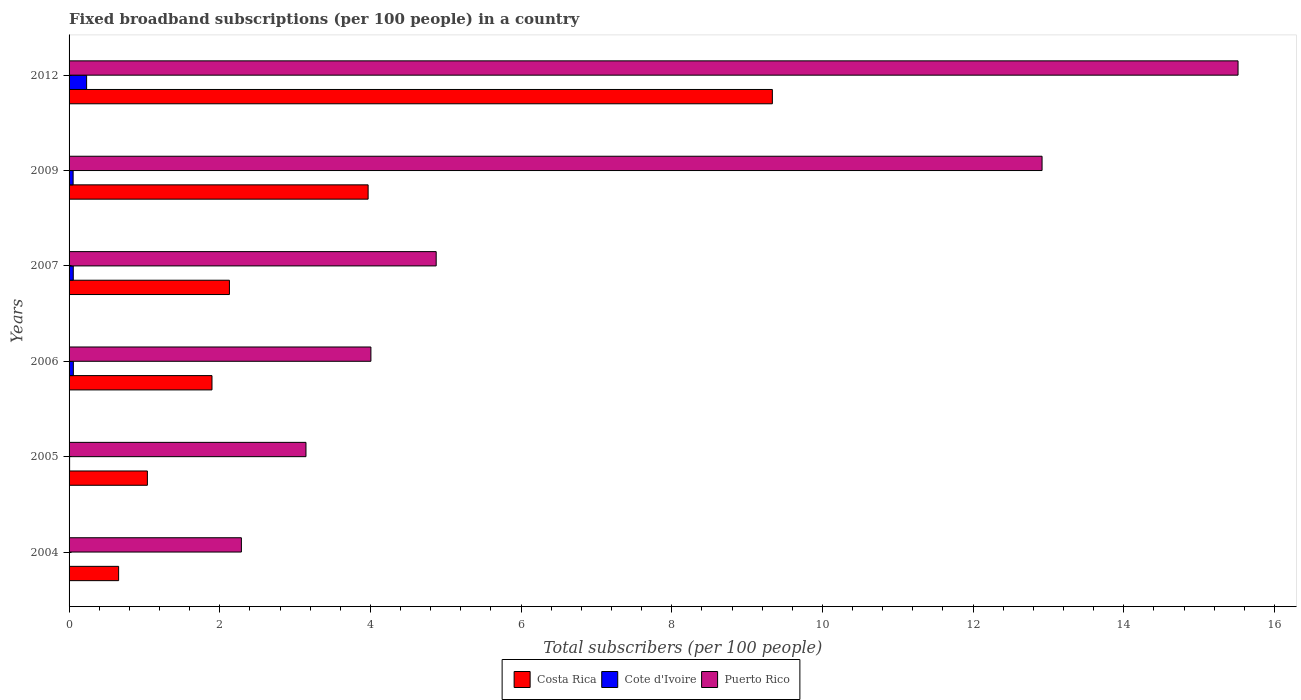How many different coloured bars are there?
Give a very brief answer. 3. How many groups of bars are there?
Make the answer very short. 6. Are the number of bars per tick equal to the number of legend labels?
Your answer should be very brief. Yes. How many bars are there on the 3rd tick from the bottom?
Give a very brief answer. 3. What is the label of the 4th group of bars from the top?
Keep it short and to the point. 2006. In how many cases, is the number of bars for a given year not equal to the number of legend labels?
Provide a short and direct response. 0. What is the number of broadband subscriptions in Costa Rica in 2009?
Provide a succinct answer. 3.97. Across all years, what is the maximum number of broadband subscriptions in Cote d'Ivoire?
Provide a succinct answer. 0.23. Across all years, what is the minimum number of broadband subscriptions in Cote d'Ivoire?
Offer a terse response. 0. In which year was the number of broadband subscriptions in Costa Rica minimum?
Keep it short and to the point. 2004. What is the total number of broadband subscriptions in Cote d'Ivoire in the graph?
Make the answer very short. 0.41. What is the difference between the number of broadband subscriptions in Puerto Rico in 2007 and that in 2012?
Provide a succinct answer. -10.64. What is the difference between the number of broadband subscriptions in Cote d'Ivoire in 2004 and the number of broadband subscriptions in Costa Rica in 2006?
Keep it short and to the point. -1.89. What is the average number of broadband subscriptions in Puerto Rico per year?
Keep it short and to the point. 7.12. In the year 2009, what is the difference between the number of broadband subscriptions in Puerto Rico and number of broadband subscriptions in Costa Rica?
Make the answer very short. 8.95. What is the ratio of the number of broadband subscriptions in Cote d'Ivoire in 2005 to that in 2006?
Provide a short and direct response. 0.13. What is the difference between the highest and the second highest number of broadband subscriptions in Costa Rica?
Provide a succinct answer. 5.37. What is the difference between the highest and the lowest number of broadband subscriptions in Puerto Rico?
Provide a succinct answer. 13.23. What does the 2nd bar from the top in 2009 represents?
Keep it short and to the point. Cote d'Ivoire. What does the 3rd bar from the bottom in 2006 represents?
Provide a succinct answer. Puerto Rico. Is it the case that in every year, the sum of the number of broadband subscriptions in Puerto Rico and number of broadband subscriptions in Costa Rica is greater than the number of broadband subscriptions in Cote d'Ivoire?
Your answer should be very brief. Yes. What is the difference between two consecutive major ticks on the X-axis?
Make the answer very short. 2. Are the values on the major ticks of X-axis written in scientific E-notation?
Keep it short and to the point. No. What is the title of the graph?
Keep it short and to the point. Fixed broadband subscriptions (per 100 people) in a country. Does "Japan" appear as one of the legend labels in the graph?
Your answer should be compact. No. What is the label or title of the X-axis?
Ensure brevity in your answer.  Total subscribers (per 100 people). What is the label or title of the Y-axis?
Offer a very short reply. Years. What is the Total subscribers (per 100 people) of Costa Rica in 2004?
Offer a terse response. 0.66. What is the Total subscribers (per 100 people) of Cote d'Ivoire in 2004?
Keep it short and to the point. 0. What is the Total subscribers (per 100 people) in Puerto Rico in 2004?
Your response must be concise. 2.29. What is the Total subscribers (per 100 people) in Costa Rica in 2005?
Make the answer very short. 1.04. What is the Total subscribers (per 100 people) of Cote d'Ivoire in 2005?
Make the answer very short. 0.01. What is the Total subscribers (per 100 people) of Puerto Rico in 2005?
Keep it short and to the point. 3.14. What is the Total subscribers (per 100 people) of Costa Rica in 2006?
Ensure brevity in your answer.  1.9. What is the Total subscribers (per 100 people) of Cote d'Ivoire in 2006?
Your answer should be compact. 0.06. What is the Total subscribers (per 100 people) of Puerto Rico in 2006?
Offer a terse response. 4.01. What is the Total subscribers (per 100 people) in Costa Rica in 2007?
Provide a succinct answer. 2.13. What is the Total subscribers (per 100 people) in Cote d'Ivoire in 2007?
Give a very brief answer. 0.06. What is the Total subscribers (per 100 people) in Puerto Rico in 2007?
Provide a succinct answer. 4.87. What is the Total subscribers (per 100 people) of Costa Rica in 2009?
Your answer should be very brief. 3.97. What is the Total subscribers (per 100 people) of Cote d'Ivoire in 2009?
Provide a succinct answer. 0.05. What is the Total subscribers (per 100 people) of Puerto Rico in 2009?
Offer a very short reply. 12.92. What is the Total subscribers (per 100 people) in Costa Rica in 2012?
Your answer should be very brief. 9.34. What is the Total subscribers (per 100 people) in Cote d'Ivoire in 2012?
Offer a very short reply. 0.23. What is the Total subscribers (per 100 people) in Puerto Rico in 2012?
Keep it short and to the point. 15.52. Across all years, what is the maximum Total subscribers (per 100 people) of Costa Rica?
Your answer should be very brief. 9.34. Across all years, what is the maximum Total subscribers (per 100 people) in Cote d'Ivoire?
Give a very brief answer. 0.23. Across all years, what is the maximum Total subscribers (per 100 people) of Puerto Rico?
Offer a very short reply. 15.52. Across all years, what is the minimum Total subscribers (per 100 people) of Costa Rica?
Offer a terse response. 0.66. Across all years, what is the minimum Total subscribers (per 100 people) in Cote d'Ivoire?
Make the answer very short. 0. Across all years, what is the minimum Total subscribers (per 100 people) in Puerto Rico?
Your response must be concise. 2.29. What is the total Total subscribers (per 100 people) of Costa Rica in the graph?
Your response must be concise. 19.03. What is the total Total subscribers (per 100 people) in Cote d'Ivoire in the graph?
Provide a short and direct response. 0.41. What is the total Total subscribers (per 100 people) of Puerto Rico in the graph?
Offer a very short reply. 42.74. What is the difference between the Total subscribers (per 100 people) in Costa Rica in 2004 and that in 2005?
Keep it short and to the point. -0.38. What is the difference between the Total subscribers (per 100 people) in Cote d'Ivoire in 2004 and that in 2005?
Make the answer very short. -0. What is the difference between the Total subscribers (per 100 people) of Puerto Rico in 2004 and that in 2005?
Make the answer very short. -0.86. What is the difference between the Total subscribers (per 100 people) of Costa Rica in 2004 and that in 2006?
Offer a very short reply. -1.24. What is the difference between the Total subscribers (per 100 people) of Cote d'Ivoire in 2004 and that in 2006?
Provide a short and direct response. -0.05. What is the difference between the Total subscribers (per 100 people) in Puerto Rico in 2004 and that in 2006?
Your answer should be compact. -1.72. What is the difference between the Total subscribers (per 100 people) of Costa Rica in 2004 and that in 2007?
Give a very brief answer. -1.47. What is the difference between the Total subscribers (per 100 people) in Cote d'Ivoire in 2004 and that in 2007?
Give a very brief answer. -0.05. What is the difference between the Total subscribers (per 100 people) in Puerto Rico in 2004 and that in 2007?
Make the answer very short. -2.59. What is the difference between the Total subscribers (per 100 people) in Costa Rica in 2004 and that in 2009?
Keep it short and to the point. -3.31. What is the difference between the Total subscribers (per 100 people) of Cote d'Ivoire in 2004 and that in 2009?
Offer a very short reply. -0.05. What is the difference between the Total subscribers (per 100 people) of Puerto Rico in 2004 and that in 2009?
Offer a very short reply. -10.63. What is the difference between the Total subscribers (per 100 people) in Costa Rica in 2004 and that in 2012?
Provide a succinct answer. -8.68. What is the difference between the Total subscribers (per 100 people) of Cote d'Ivoire in 2004 and that in 2012?
Offer a terse response. -0.23. What is the difference between the Total subscribers (per 100 people) in Puerto Rico in 2004 and that in 2012?
Provide a short and direct response. -13.23. What is the difference between the Total subscribers (per 100 people) in Costa Rica in 2005 and that in 2006?
Provide a succinct answer. -0.86. What is the difference between the Total subscribers (per 100 people) of Cote d'Ivoire in 2005 and that in 2006?
Ensure brevity in your answer.  -0.05. What is the difference between the Total subscribers (per 100 people) of Puerto Rico in 2005 and that in 2006?
Keep it short and to the point. -0.86. What is the difference between the Total subscribers (per 100 people) in Costa Rica in 2005 and that in 2007?
Provide a succinct answer. -1.09. What is the difference between the Total subscribers (per 100 people) of Cote d'Ivoire in 2005 and that in 2007?
Your answer should be compact. -0.05. What is the difference between the Total subscribers (per 100 people) of Puerto Rico in 2005 and that in 2007?
Provide a succinct answer. -1.73. What is the difference between the Total subscribers (per 100 people) of Costa Rica in 2005 and that in 2009?
Provide a succinct answer. -2.93. What is the difference between the Total subscribers (per 100 people) of Cote d'Ivoire in 2005 and that in 2009?
Ensure brevity in your answer.  -0.05. What is the difference between the Total subscribers (per 100 people) in Puerto Rico in 2005 and that in 2009?
Your answer should be very brief. -9.77. What is the difference between the Total subscribers (per 100 people) in Costa Rica in 2005 and that in 2012?
Your answer should be very brief. -8.3. What is the difference between the Total subscribers (per 100 people) of Cote d'Ivoire in 2005 and that in 2012?
Provide a short and direct response. -0.23. What is the difference between the Total subscribers (per 100 people) of Puerto Rico in 2005 and that in 2012?
Your answer should be very brief. -12.37. What is the difference between the Total subscribers (per 100 people) of Costa Rica in 2006 and that in 2007?
Provide a succinct answer. -0.23. What is the difference between the Total subscribers (per 100 people) of Cote d'Ivoire in 2006 and that in 2007?
Offer a terse response. 0. What is the difference between the Total subscribers (per 100 people) of Puerto Rico in 2006 and that in 2007?
Provide a short and direct response. -0.87. What is the difference between the Total subscribers (per 100 people) in Costa Rica in 2006 and that in 2009?
Your response must be concise. -2.07. What is the difference between the Total subscribers (per 100 people) of Cote d'Ivoire in 2006 and that in 2009?
Offer a very short reply. 0. What is the difference between the Total subscribers (per 100 people) of Puerto Rico in 2006 and that in 2009?
Make the answer very short. -8.91. What is the difference between the Total subscribers (per 100 people) in Costa Rica in 2006 and that in 2012?
Make the answer very short. -7.44. What is the difference between the Total subscribers (per 100 people) of Cote d'Ivoire in 2006 and that in 2012?
Offer a very short reply. -0.18. What is the difference between the Total subscribers (per 100 people) in Puerto Rico in 2006 and that in 2012?
Your answer should be very brief. -11.51. What is the difference between the Total subscribers (per 100 people) in Costa Rica in 2007 and that in 2009?
Offer a very short reply. -1.84. What is the difference between the Total subscribers (per 100 people) of Cote d'Ivoire in 2007 and that in 2009?
Keep it short and to the point. 0. What is the difference between the Total subscribers (per 100 people) of Puerto Rico in 2007 and that in 2009?
Your answer should be compact. -8.04. What is the difference between the Total subscribers (per 100 people) in Costa Rica in 2007 and that in 2012?
Make the answer very short. -7.21. What is the difference between the Total subscribers (per 100 people) in Cote d'Ivoire in 2007 and that in 2012?
Your answer should be very brief. -0.18. What is the difference between the Total subscribers (per 100 people) of Puerto Rico in 2007 and that in 2012?
Your response must be concise. -10.64. What is the difference between the Total subscribers (per 100 people) in Costa Rica in 2009 and that in 2012?
Offer a very short reply. -5.37. What is the difference between the Total subscribers (per 100 people) in Cote d'Ivoire in 2009 and that in 2012?
Ensure brevity in your answer.  -0.18. What is the difference between the Total subscribers (per 100 people) in Puerto Rico in 2009 and that in 2012?
Your answer should be compact. -2.6. What is the difference between the Total subscribers (per 100 people) in Costa Rica in 2004 and the Total subscribers (per 100 people) in Cote d'Ivoire in 2005?
Your answer should be very brief. 0.65. What is the difference between the Total subscribers (per 100 people) in Costa Rica in 2004 and the Total subscribers (per 100 people) in Puerto Rico in 2005?
Make the answer very short. -2.49. What is the difference between the Total subscribers (per 100 people) in Cote d'Ivoire in 2004 and the Total subscribers (per 100 people) in Puerto Rico in 2005?
Offer a very short reply. -3.14. What is the difference between the Total subscribers (per 100 people) of Costa Rica in 2004 and the Total subscribers (per 100 people) of Cote d'Ivoire in 2006?
Your answer should be compact. 0.6. What is the difference between the Total subscribers (per 100 people) of Costa Rica in 2004 and the Total subscribers (per 100 people) of Puerto Rico in 2006?
Keep it short and to the point. -3.35. What is the difference between the Total subscribers (per 100 people) in Cote d'Ivoire in 2004 and the Total subscribers (per 100 people) in Puerto Rico in 2006?
Provide a short and direct response. -4. What is the difference between the Total subscribers (per 100 people) of Costa Rica in 2004 and the Total subscribers (per 100 people) of Cote d'Ivoire in 2007?
Ensure brevity in your answer.  0.6. What is the difference between the Total subscribers (per 100 people) of Costa Rica in 2004 and the Total subscribers (per 100 people) of Puerto Rico in 2007?
Keep it short and to the point. -4.22. What is the difference between the Total subscribers (per 100 people) in Cote d'Ivoire in 2004 and the Total subscribers (per 100 people) in Puerto Rico in 2007?
Your answer should be very brief. -4.87. What is the difference between the Total subscribers (per 100 people) of Costa Rica in 2004 and the Total subscribers (per 100 people) of Cote d'Ivoire in 2009?
Keep it short and to the point. 0.6. What is the difference between the Total subscribers (per 100 people) of Costa Rica in 2004 and the Total subscribers (per 100 people) of Puerto Rico in 2009?
Offer a terse response. -12.26. What is the difference between the Total subscribers (per 100 people) in Cote d'Ivoire in 2004 and the Total subscribers (per 100 people) in Puerto Rico in 2009?
Provide a succinct answer. -12.91. What is the difference between the Total subscribers (per 100 people) of Costa Rica in 2004 and the Total subscribers (per 100 people) of Cote d'Ivoire in 2012?
Keep it short and to the point. 0.43. What is the difference between the Total subscribers (per 100 people) of Costa Rica in 2004 and the Total subscribers (per 100 people) of Puerto Rico in 2012?
Your response must be concise. -14.86. What is the difference between the Total subscribers (per 100 people) in Cote d'Ivoire in 2004 and the Total subscribers (per 100 people) in Puerto Rico in 2012?
Offer a very short reply. -15.51. What is the difference between the Total subscribers (per 100 people) in Costa Rica in 2005 and the Total subscribers (per 100 people) in Puerto Rico in 2006?
Provide a short and direct response. -2.97. What is the difference between the Total subscribers (per 100 people) in Cote d'Ivoire in 2005 and the Total subscribers (per 100 people) in Puerto Rico in 2006?
Make the answer very short. -4. What is the difference between the Total subscribers (per 100 people) of Costa Rica in 2005 and the Total subscribers (per 100 people) of Cote d'Ivoire in 2007?
Your response must be concise. 0.98. What is the difference between the Total subscribers (per 100 people) of Costa Rica in 2005 and the Total subscribers (per 100 people) of Puerto Rico in 2007?
Provide a succinct answer. -3.83. What is the difference between the Total subscribers (per 100 people) of Cote d'Ivoire in 2005 and the Total subscribers (per 100 people) of Puerto Rico in 2007?
Your answer should be very brief. -4.87. What is the difference between the Total subscribers (per 100 people) in Costa Rica in 2005 and the Total subscribers (per 100 people) in Cote d'Ivoire in 2009?
Offer a very short reply. 0.99. What is the difference between the Total subscribers (per 100 people) of Costa Rica in 2005 and the Total subscribers (per 100 people) of Puerto Rico in 2009?
Your answer should be very brief. -11.88. What is the difference between the Total subscribers (per 100 people) of Cote d'Ivoire in 2005 and the Total subscribers (per 100 people) of Puerto Rico in 2009?
Give a very brief answer. -12.91. What is the difference between the Total subscribers (per 100 people) in Costa Rica in 2005 and the Total subscribers (per 100 people) in Cote d'Ivoire in 2012?
Your response must be concise. 0.81. What is the difference between the Total subscribers (per 100 people) in Costa Rica in 2005 and the Total subscribers (per 100 people) in Puerto Rico in 2012?
Your answer should be very brief. -14.48. What is the difference between the Total subscribers (per 100 people) in Cote d'Ivoire in 2005 and the Total subscribers (per 100 people) in Puerto Rico in 2012?
Offer a terse response. -15.51. What is the difference between the Total subscribers (per 100 people) in Costa Rica in 2006 and the Total subscribers (per 100 people) in Cote d'Ivoire in 2007?
Provide a succinct answer. 1.84. What is the difference between the Total subscribers (per 100 people) of Costa Rica in 2006 and the Total subscribers (per 100 people) of Puerto Rico in 2007?
Provide a succinct answer. -2.98. What is the difference between the Total subscribers (per 100 people) in Cote d'Ivoire in 2006 and the Total subscribers (per 100 people) in Puerto Rico in 2007?
Provide a succinct answer. -4.82. What is the difference between the Total subscribers (per 100 people) of Costa Rica in 2006 and the Total subscribers (per 100 people) of Cote d'Ivoire in 2009?
Offer a very short reply. 1.84. What is the difference between the Total subscribers (per 100 people) of Costa Rica in 2006 and the Total subscribers (per 100 people) of Puerto Rico in 2009?
Offer a terse response. -11.02. What is the difference between the Total subscribers (per 100 people) in Cote d'Ivoire in 2006 and the Total subscribers (per 100 people) in Puerto Rico in 2009?
Your answer should be very brief. -12.86. What is the difference between the Total subscribers (per 100 people) of Costa Rica in 2006 and the Total subscribers (per 100 people) of Cote d'Ivoire in 2012?
Provide a succinct answer. 1.66. What is the difference between the Total subscribers (per 100 people) in Costa Rica in 2006 and the Total subscribers (per 100 people) in Puerto Rico in 2012?
Your answer should be very brief. -13.62. What is the difference between the Total subscribers (per 100 people) of Cote d'Ivoire in 2006 and the Total subscribers (per 100 people) of Puerto Rico in 2012?
Provide a succinct answer. -15.46. What is the difference between the Total subscribers (per 100 people) in Costa Rica in 2007 and the Total subscribers (per 100 people) in Cote d'Ivoire in 2009?
Your response must be concise. 2.07. What is the difference between the Total subscribers (per 100 people) of Costa Rica in 2007 and the Total subscribers (per 100 people) of Puerto Rico in 2009?
Your response must be concise. -10.79. What is the difference between the Total subscribers (per 100 people) in Cote d'Ivoire in 2007 and the Total subscribers (per 100 people) in Puerto Rico in 2009?
Make the answer very short. -12.86. What is the difference between the Total subscribers (per 100 people) in Costa Rica in 2007 and the Total subscribers (per 100 people) in Cote d'Ivoire in 2012?
Keep it short and to the point. 1.9. What is the difference between the Total subscribers (per 100 people) in Costa Rica in 2007 and the Total subscribers (per 100 people) in Puerto Rico in 2012?
Offer a very short reply. -13.39. What is the difference between the Total subscribers (per 100 people) of Cote d'Ivoire in 2007 and the Total subscribers (per 100 people) of Puerto Rico in 2012?
Give a very brief answer. -15.46. What is the difference between the Total subscribers (per 100 people) in Costa Rica in 2009 and the Total subscribers (per 100 people) in Cote d'Ivoire in 2012?
Your answer should be very brief. 3.74. What is the difference between the Total subscribers (per 100 people) of Costa Rica in 2009 and the Total subscribers (per 100 people) of Puerto Rico in 2012?
Offer a very short reply. -11.55. What is the difference between the Total subscribers (per 100 people) in Cote d'Ivoire in 2009 and the Total subscribers (per 100 people) in Puerto Rico in 2012?
Your answer should be compact. -15.46. What is the average Total subscribers (per 100 people) in Costa Rica per year?
Give a very brief answer. 3.17. What is the average Total subscribers (per 100 people) in Cote d'Ivoire per year?
Make the answer very short. 0.07. What is the average Total subscribers (per 100 people) in Puerto Rico per year?
Your answer should be compact. 7.12. In the year 2004, what is the difference between the Total subscribers (per 100 people) in Costa Rica and Total subscribers (per 100 people) in Cote d'Ivoire?
Offer a very short reply. 0.65. In the year 2004, what is the difference between the Total subscribers (per 100 people) in Costa Rica and Total subscribers (per 100 people) in Puerto Rico?
Provide a short and direct response. -1.63. In the year 2004, what is the difference between the Total subscribers (per 100 people) of Cote d'Ivoire and Total subscribers (per 100 people) of Puerto Rico?
Your response must be concise. -2.28. In the year 2005, what is the difference between the Total subscribers (per 100 people) in Costa Rica and Total subscribers (per 100 people) in Cote d'Ivoire?
Give a very brief answer. 1.03. In the year 2005, what is the difference between the Total subscribers (per 100 people) in Costa Rica and Total subscribers (per 100 people) in Puerto Rico?
Ensure brevity in your answer.  -2.1. In the year 2005, what is the difference between the Total subscribers (per 100 people) in Cote d'Ivoire and Total subscribers (per 100 people) in Puerto Rico?
Give a very brief answer. -3.14. In the year 2006, what is the difference between the Total subscribers (per 100 people) in Costa Rica and Total subscribers (per 100 people) in Cote d'Ivoire?
Make the answer very short. 1.84. In the year 2006, what is the difference between the Total subscribers (per 100 people) of Costa Rica and Total subscribers (per 100 people) of Puerto Rico?
Make the answer very short. -2.11. In the year 2006, what is the difference between the Total subscribers (per 100 people) of Cote d'Ivoire and Total subscribers (per 100 people) of Puerto Rico?
Give a very brief answer. -3.95. In the year 2007, what is the difference between the Total subscribers (per 100 people) of Costa Rica and Total subscribers (per 100 people) of Cote d'Ivoire?
Offer a terse response. 2.07. In the year 2007, what is the difference between the Total subscribers (per 100 people) in Costa Rica and Total subscribers (per 100 people) in Puerto Rico?
Offer a terse response. -2.74. In the year 2007, what is the difference between the Total subscribers (per 100 people) in Cote d'Ivoire and Total subscribers (per 100 people) in Puerto Rico?
Keep it short and to the point. -4.82. In the year 2009, what is the difference between the Total subscribers (per 100 people) of Costa Rica and Total subscribers (per 100 people) of Cote d'Ivoire?
Give a very brief answer. 3.92. In the year 2009, what is the difference between the Total subscribers (per 100 people) in Costa Rica and Total subscribers (per 100 people) in Puerto Rico?
Offer a terse response. -8.95. In the year 2009, what is the difference between the Total subscribers (per 100 people) in Cote d'Ivoire and Total subscribers (per 100 people) in Puerto Rico?
Ensure brevity in your answer.  -12.86. In the year 2012, what is the difference between the Total subscribers (per 100 people) of Costa Rica and Total subscribers (per 100 people) of Cote d'Ivoire?
Provide a succinct answer. 9.1. In the year 2012, what is the difference between the Total subscribers (per 100 people) of Costa Rica and Total subscribers (per 100 people) of Puerto Rico?
Make the answer very short. -6.18. In the year 2012, what is the difference between the Total subscribers (per 100 people) of Cote d'Ivoire and Total subscribers (per 100 people) of Puerto Rico?
Offer a terse response. -15.28. What is the ratio of the Total subscribers (per 100 people) of Costa Rica in 2004 to that in 2005?
Provide a succinct answer. 0.63. What is the ratio of the Total subscribers (per 100 people) in Cote d'Ivoire in 2004 to that in 2005?
Your response must be concise. 0.68. What is the ratio of the Total subscribers (per 100 people) of Puerto Rico in 2004 to that in 2005?
Your answer should be compact. 0.73. What is the ratio of the Total subscribers (per 100 people) in Costa Rica in 2004 to that in 2006?
Make the answer very short. 0.35. What is the ratio of the Total subscribers (per 100 people) of Cote d'Ivoire in 2004 to that in 2006?
Provide a short and direct response. 0.09. What is the ratio of the Total subscribers (per 100 people) of Puerto Rico in 2004 to that in 2006?
Keep it short and to the point. 0.57. What is the ratio of the Total subscribers (per 100 people) in Costa Rica in 2004 to that in 2007?
Keep it short and to the point. 0.31. What is the ratio of the Total subscribers (per 100 people) of Cote d'Ivoire in 2004 to that in 2007?
Keep it short and to the point. 0.09. What is the ratio of the Total subscribers (per 100 people) of Puerto Rico in 2004 to that in 2007?
Your response must be concise. 0.47. What is the ratio of the Total subscribers (per 100 people) of Costa Rica in 2004 to that in 2009?
Your answer should be very brief. 0.17. What is the ratio of the Total subscribers (per 100 people) in Cote d'Ivoire in 2004 to that in 2009?
Your response must be concise. 0.09. What is the ratio of the Total subscribers (per 100 people) in Puerto Rico in 2004 to that in 2009?
Your answer should be compact. 0.18. What is the ratio of the Total subscribers (per 100 people) in Costa Rica in 2004 to that in 2012?
Make the answer very short. 0.07. What is the ratio of the Total subscribers (per 100 people) in Cote d'Ivoire in 2004 to that in 2012?
Your response must be concise. 0.02. What is the ratio of the Total subscribers (per 100 people) in Puerto Rico in 2004 to that in 2012?
Your answer should be compact. 0.15. What is the ratio of the Total subscribers (per 100 people) of Costa Rica in 2005 to that in 2006?
Keep it short and to the point. 0.55. What is the ratio of the Total subscribers (per 100 people) in Cote d'Ivoire in 2005 to that in 2006?
Give a very brief answer. 0.13. What is the ratio of the Total subscribers (per 100 people) of Puerto Rico in 2005 to that in 2006?
Provide a succinct answer. 0.78. What is the ratio of the Total subscribers (per 100 people) in Costa Rica in 2005 to that in 2007?
Offer a terse response. 0.49. What is the ratio of the Total subscribers (per 100 people) of Cote d'Ivoire in 2005 to that in 2007?
Your answer should be compact. 0.13. What is the ratio of the Total subscribers (per 100 people) of Puerto Rico in 2005 to that in 2007?
Provide a short and direct response. 0.65. What is the ratio of the Total subscribers (per 100 people) of Costa Rica in 2005 to that in 2009?
Your response must be concise. 0.26. What is the ratio of the Total subscribers (per 100 people) of Cote d'Ivoire in 2005 to that in 2009?
Give a very brief answer. 0.13. What is the ratio of the Total subscribers (per 100 people) in Puerto Rico in 2005 to that in 2009?
Provide a short and direct response. 0.24. What is the ratio of the Total subscribers (per 100 people) in Costa Rica in 2005 to that in 2012?
Your response must be concise. 0.11. What is the ratio of the Total subscribers (per 100 people) in Cote d'Ivoire in 2005 to that in 2012?
Provide a short and direct response. 0.03. What is the ratio of the Total subscribers (per 100 people) in Puerto Rico in 2005 to that in 2012?
Ensure brevity in your answer.  0.2. What is the ratio of the Total subscribers (per 100 people) of Costa Rica in 2006 to that in 2007?
Keep it short and to the point. 0.89. What is the ratio of the Total subscribers (per 100 people) of Cote d'Ivoire in 2006 to that in 2007?
Give a very brief answer. 1.02. What is the ratio of the Total subscribers (per 100 people) of Puerto Rico in 2006 to that in 2007?
Offer a very short reply. 0.82. What is the ratio of the Total subscribers (per 100 people) in Costa Rica in 2006 to that in 2009?
Offer a terse response. 0.48. What is the ratio of the Total subscribers (per 100 people) in Cote d'Ivoire in 2006 to that in 2009?
Offer a very short reply. 1.05. What is the ratio of the Total subscribers (per 100 people) in Puerto Rico in 2006 to that in 2009?
Your response must be concise. 0.31. What is the ratio of the Total subscribers (per 100 people) in Costa Rica in 2006 to that in 2012?
Your answer should be very brief. 0.2. What is the ratio of the Total subscribers (per 100 people) of Cote d'Ivoire in 2006 to that in 2012?
Keep it short and to the point. 0.24. What is the ratio of the Total subscribers (per 100 people) of Puerto Rico in 2006 to that in 2012?
Provide a short and direct response. 0.26. What is the ratio of the Total subscribers (per 100 people) of Costa Rica in 2007 to that in 2009?
Offer a very short reply. 0.54. What is the ratio of the Total subscribers (per 100 people) of Cote d'Ivoire in 2007 to that in 2009?
Provide a short and direct response. 1.04. What is the ratio of the Total subscribers (per 100 people) of Puerto Rico in 2007 to that in 2009?
Your response must be concise. 0.38. What is the ratio of the Total subscribers (per 100 people) in Costa Rica in 2007 to that in 2012?
Your answer should be very brief. 0.23. What is the ratio of the Total subscribers (per 100 people) of Cote d'Ivoire in 2007 to that in 2012?
Offer a very short reply. 0.24. What is the ratio of the Total subscribers (per 100 people) of Puerto Rico in 2007 to that in 2012?
Offer a very short reply. 0.31. What is the ratio of the Total subscribers (per 100 people) in Costa Rica in 2009 to that in 2012?
Your answer should be very brief. 0.43. What is the ratio of the Total subscribers (per 100 people) of Cote d'Ivoire in 2009 to that in 2012?
Ensure brevity in your answer.  0.23. What is the ratio of the Total subscribers (per 100 people) in Puerto Rico in 2009 to that in 2012?
Your answer should be compact. 0.83. What is the difference between the highest and the second highest Total subscribers (per 100 people) of Costa Rica?
Offer a terse response. 5.37. What is the difference between the highest and the second highest Total subscribers (per 100 people) of Cote d'Ivoire?
Your answer should be compact. 0.18. What is the difference between the highest and the second highest Total subscribers (per 100 people) of Puerto Rico?
Offer a very short reply. 2.6. What is the difference between the highest and the lowest Total subscribers (per 100 people) in Costa Rica?
Provide a succinct answer. 8.68. What is the difference between the highest and the lowest Total subscribers (per 100 people) in Cote d'Ivoire?
Provide a short and direct response. 0.23. What is the difference between the highest and the lowest Total subscribers (per 100 people) in Puerto Rico?
Keep it short and to the point. 13.23. 